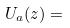Convert formula to latex. <formula><loc_0><loc_0><loc_500><loc_500>U _ { a } ( z ) =</formula> 